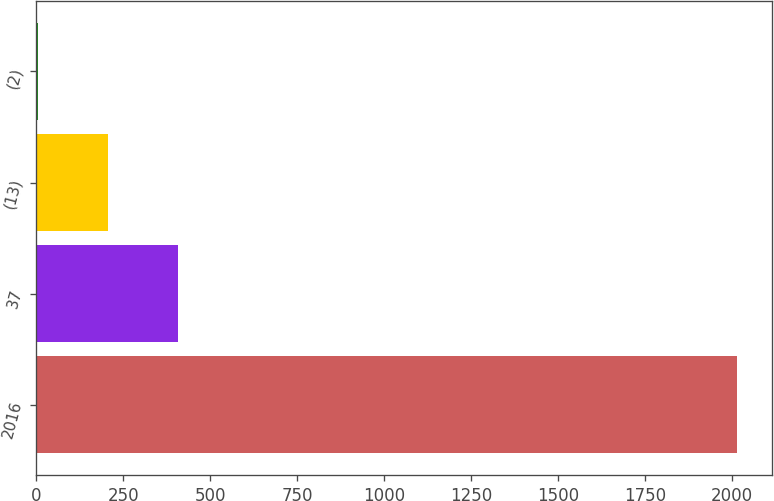Convert chart to OTSL. <chart><loc_0><loc_0><loc_500><loc_500><bar_chart><fcel>2016<fcel>37<fcel>(13)<fcel>(2)<nl><fcel>2014<fcel>407.6<fcel>206.8<fcel>6<nl></chart> 